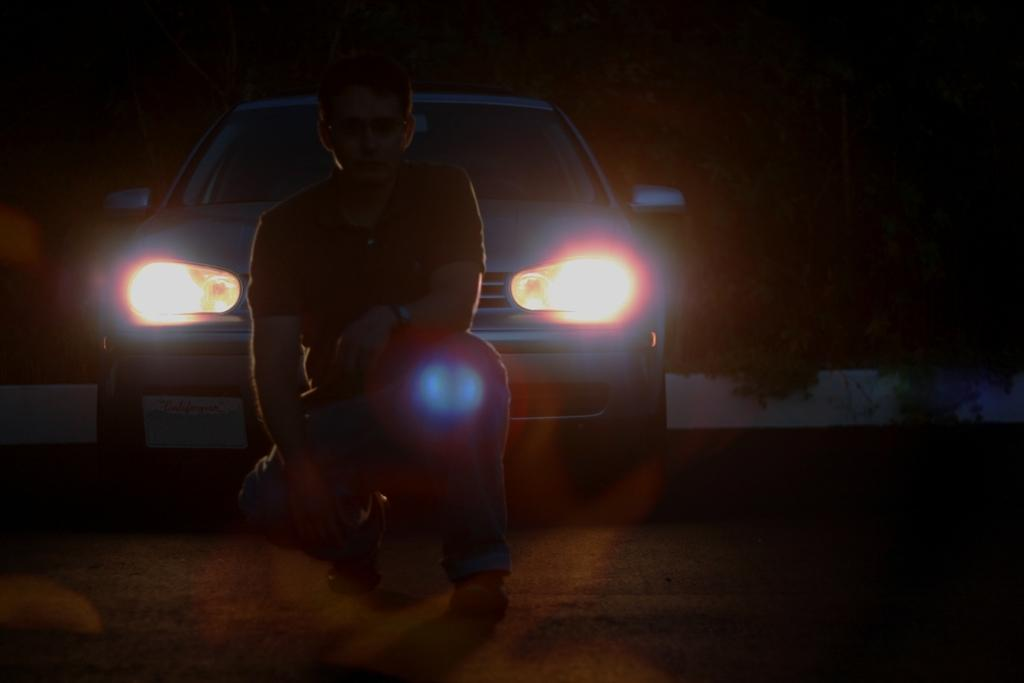Who or what is present in the image? There is a person in the image. What can be seen in the background of the image? There is a vehicle in the background of the image. What feature of the vehicle is visible in the image? The vehicle's headlights are visible in the image. What type of record is being played by the person in the image? There is no record or music player present in the image, so it cannot be determined if a record is being played. 